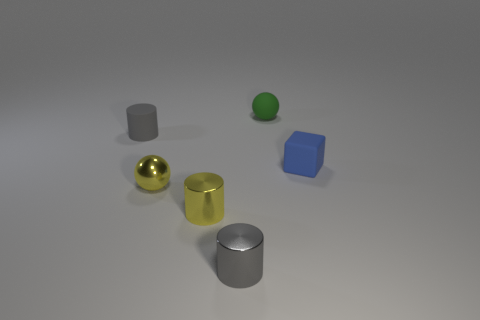Add 4 tiny yellow spheres. How many objects exist? 10 Subtract all spheres. How many objects are left? 4 Subtract all yellow metal things. Subtract all tiny green rubber things. How many objects are left? 3 Add 1 small green matte objects. How many small green matte objects are left? 2 Add 3 gray things. How many gray things exist? 5 Subtract 0 red balls. How many objects are left? 6 